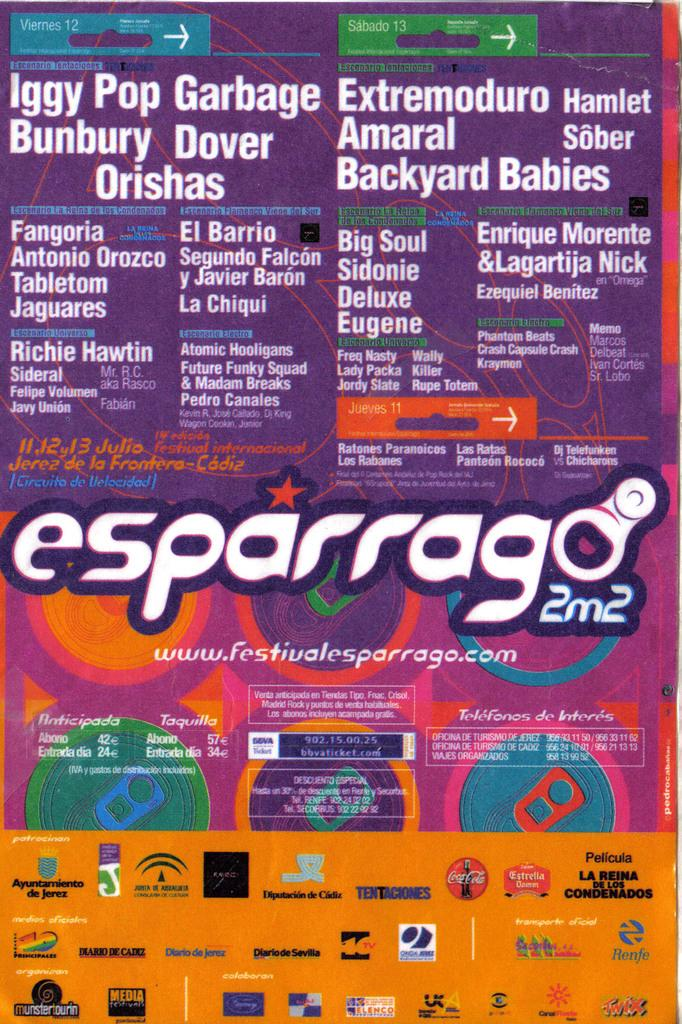<image>
Offer a succinct explanation of the picture presented. A colorful sign has Iggy Pop Garbage in the upper left corner. 